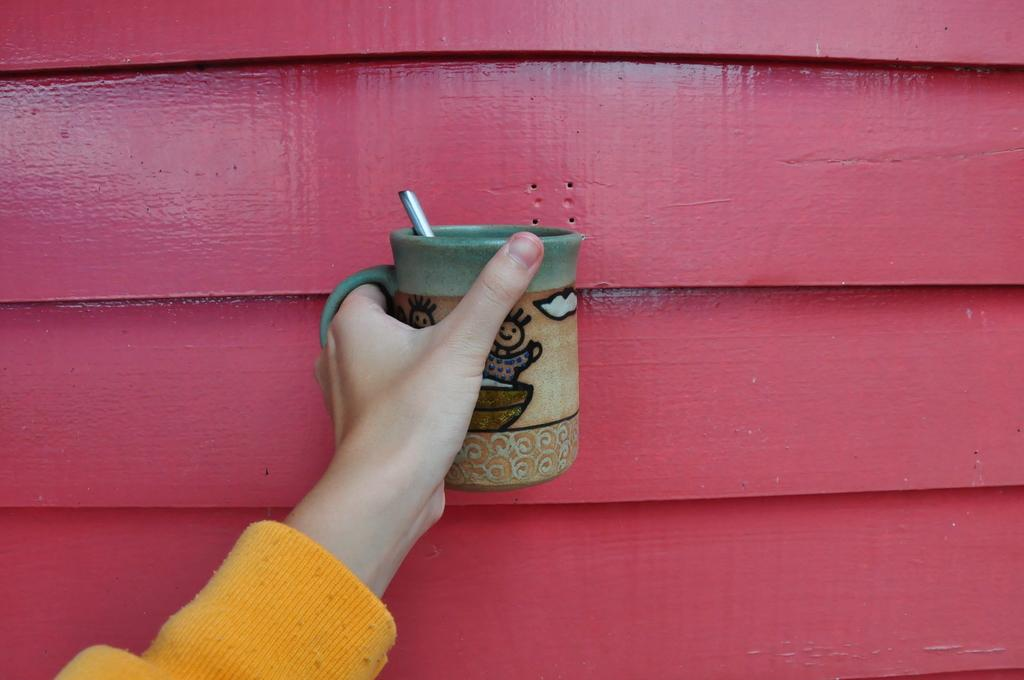Who or what is the main subject of the image? There is a person in the image. What is the person holding in the image? The person is holding a coffee mug. What color is the sweater the person is wearing? The person is wearing a yellow sweater. What can be seen in the background of the image? There is a pink wall in the background of the image. What type of bread is the person eating in the image? There is no bread present in the image; the person is holding a coffee mug. What is the relation between the person and the thing in the image? There is no "thing" mentioned in the provided facts, and the person's relation to the coffee mug is that they are holding it. 